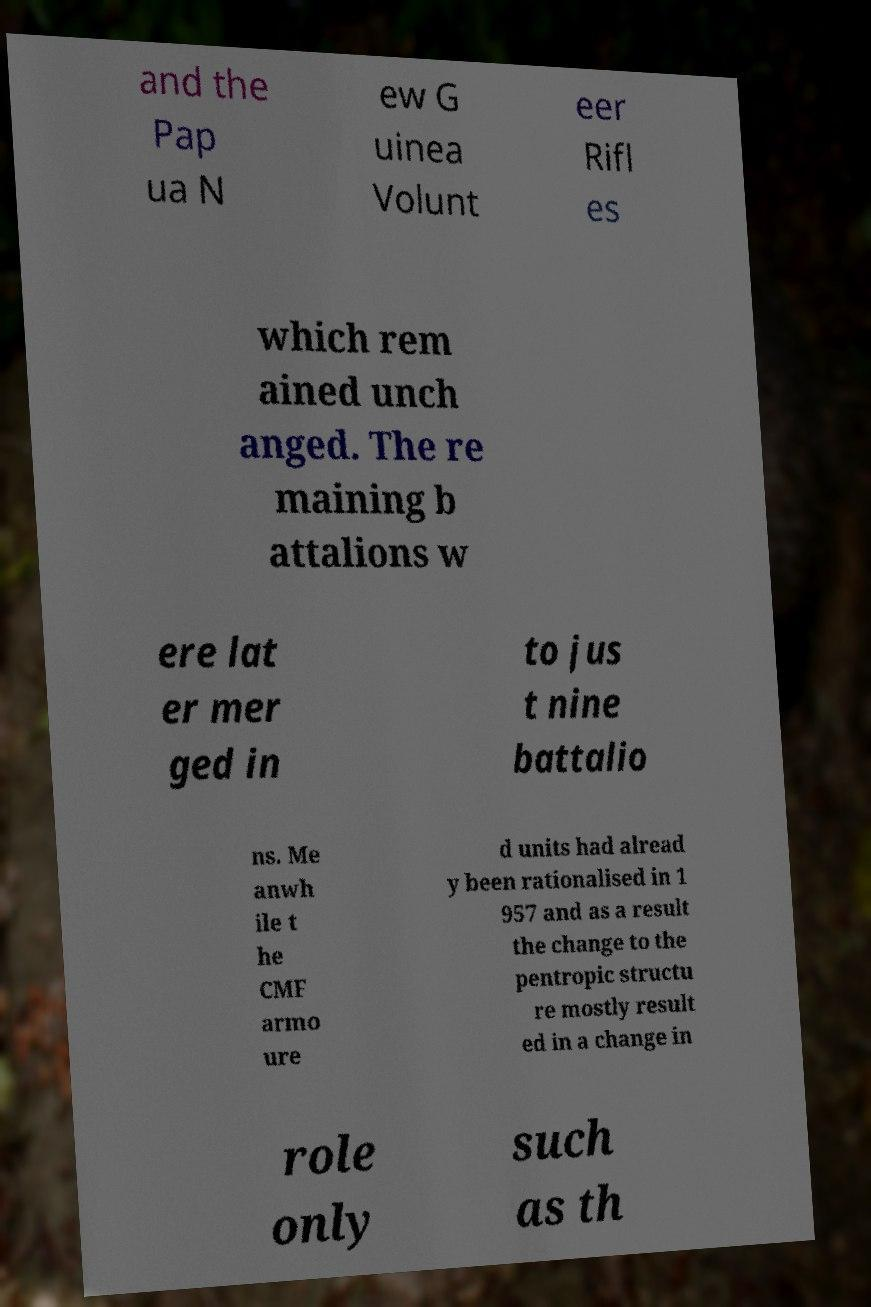What messages or text are displayed in this image? I need them in a readable, typed format. and the Pap ua N ew G uinea Volunt eer Rifl es which rem ained unch anged. The re maining b attalions w ere lat er mer ged in to jus t nine battalio ns. Me anwh ile t he CMF armo ure d units had alread y been rationalised in 1 957 and as a result the change to the pentropic structu re mostly result ed in a change in role only such as th 